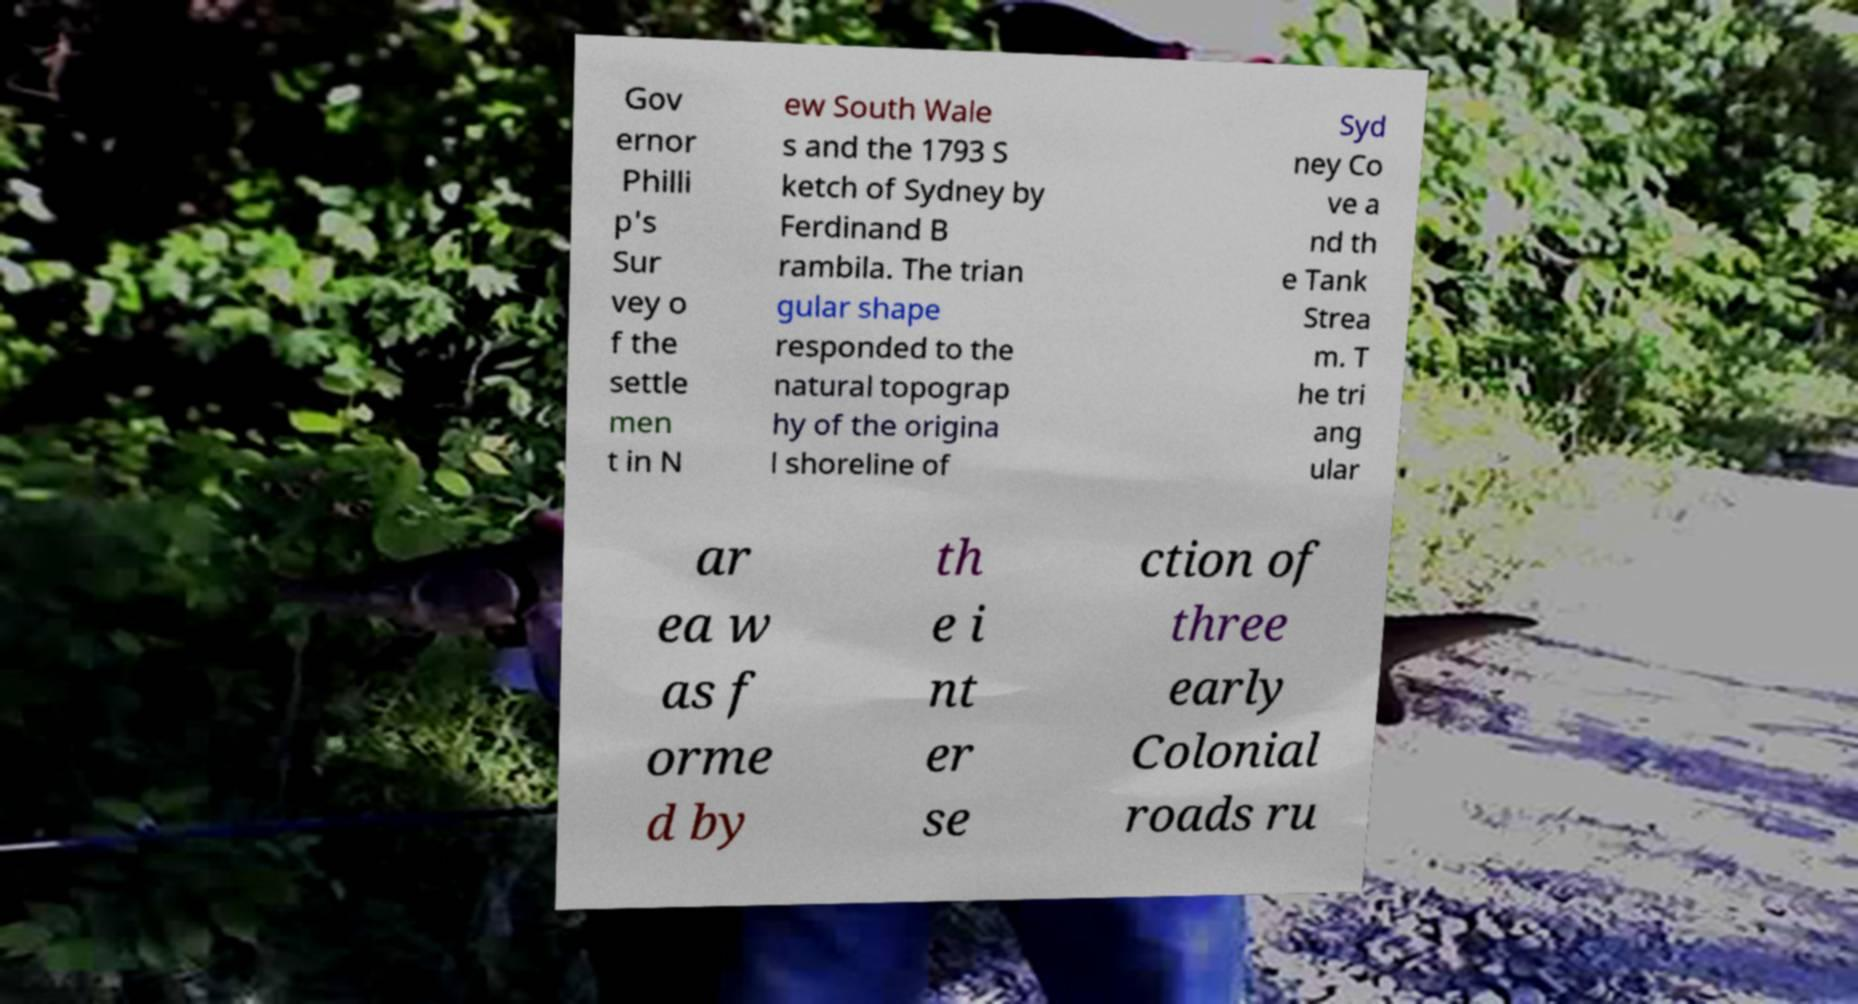Could you extract and type out the text from this image? Gov ernor Philli p's Sur vey o f the settle men t in N ew South Wale s and the 1793 S ketch of Sydney by Ferdinand B rambila. The trian gular shape responded to the natural topograp hy of the origina l shoreline of Syd ney Co ve a nd th e Tank Strea m. T he tri ang ular ar ea w as f orme d by th e i nt er se ction of three early Colonial roads ru 